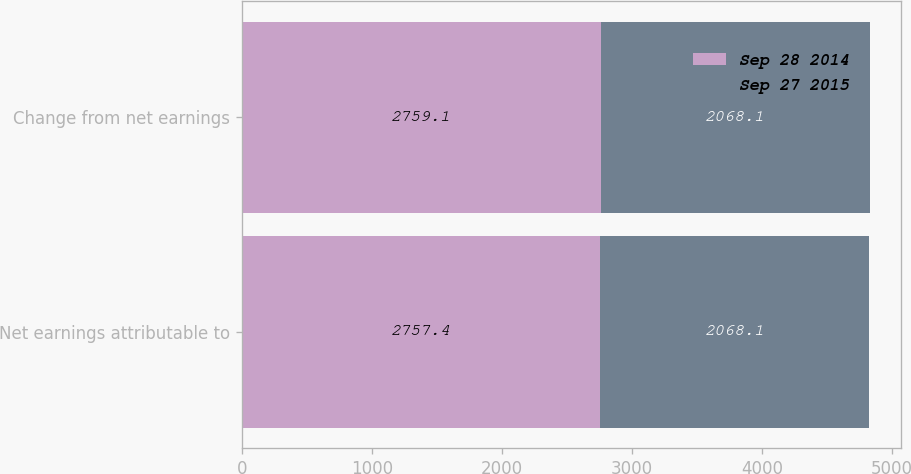<chart> <loc_0><loc_0><loc_500><loc_500><stacked_bar_chart><ecel><fcel>Net earnings attributable to<fcel>Change from net earnings<nl><fcel>Sep 28 2014<fcel>2757.4<fcel>2759.1<nl><fcel>Sep 27 2015<fcel>2068.1<fcel>2068.1<nl></chart> 